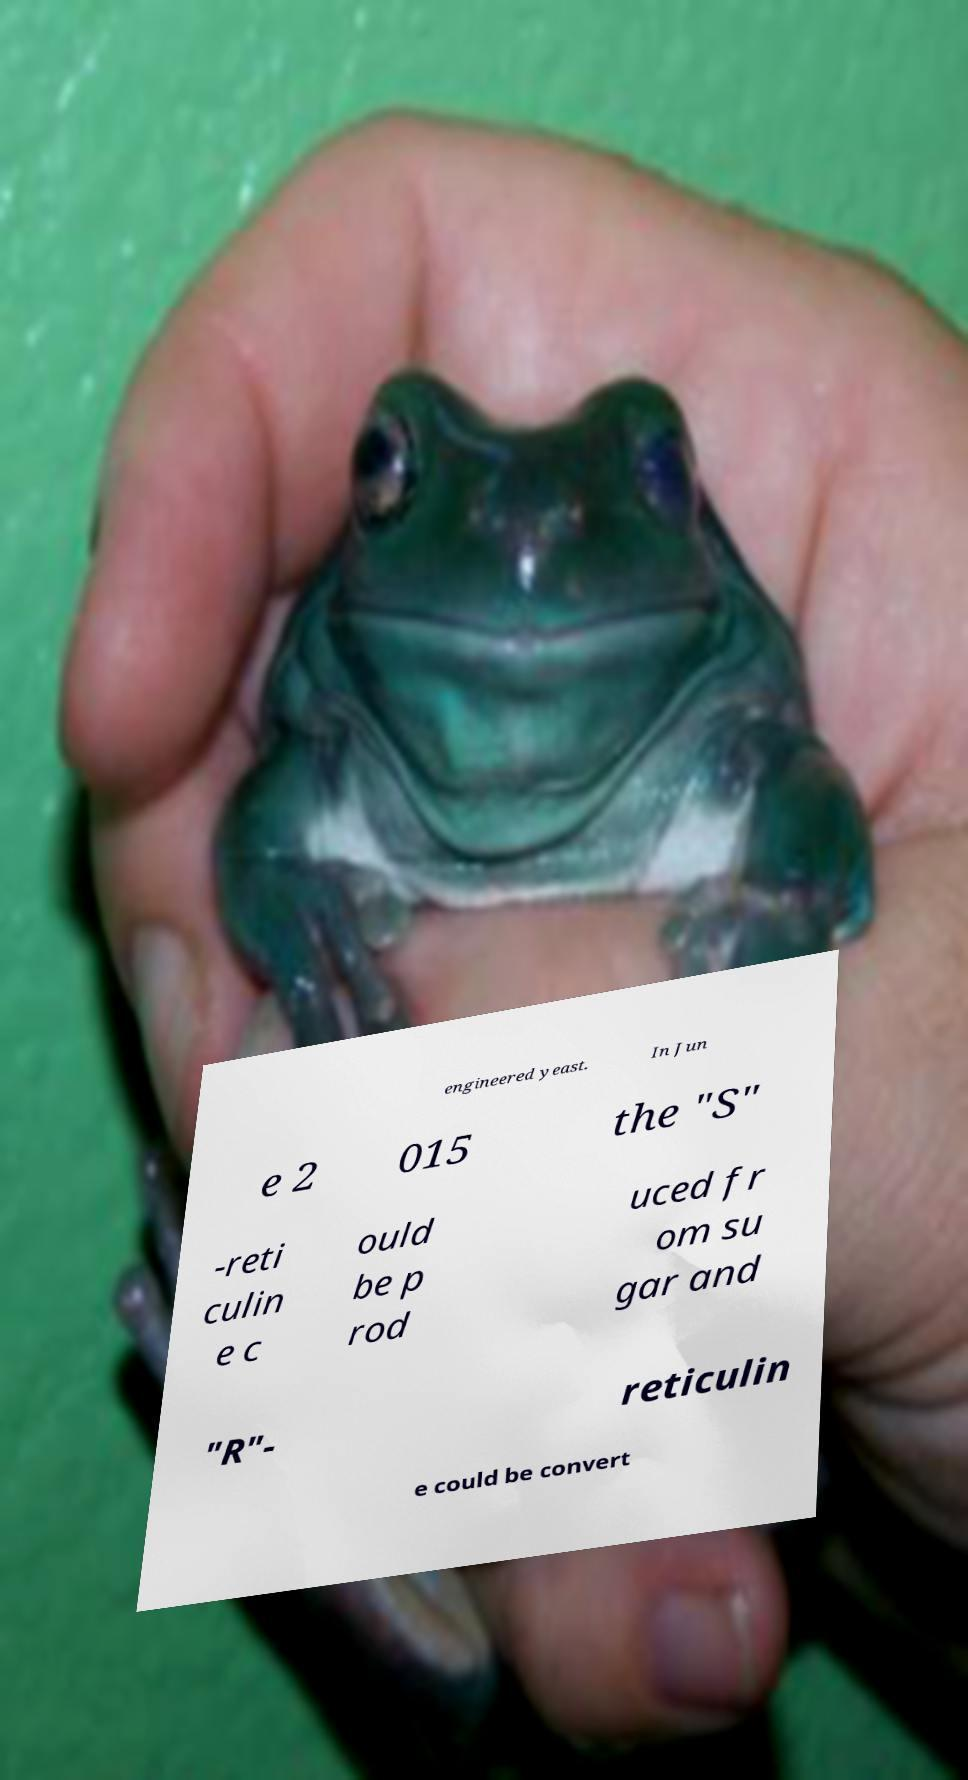Could you assist in decoding the text presented in this image and type it out clearly? engineered yeast. In Jun e 2 015 the "S" -reti culin e c ould be p rod uced fr om su gar and "R"- reticulin e could be convert 